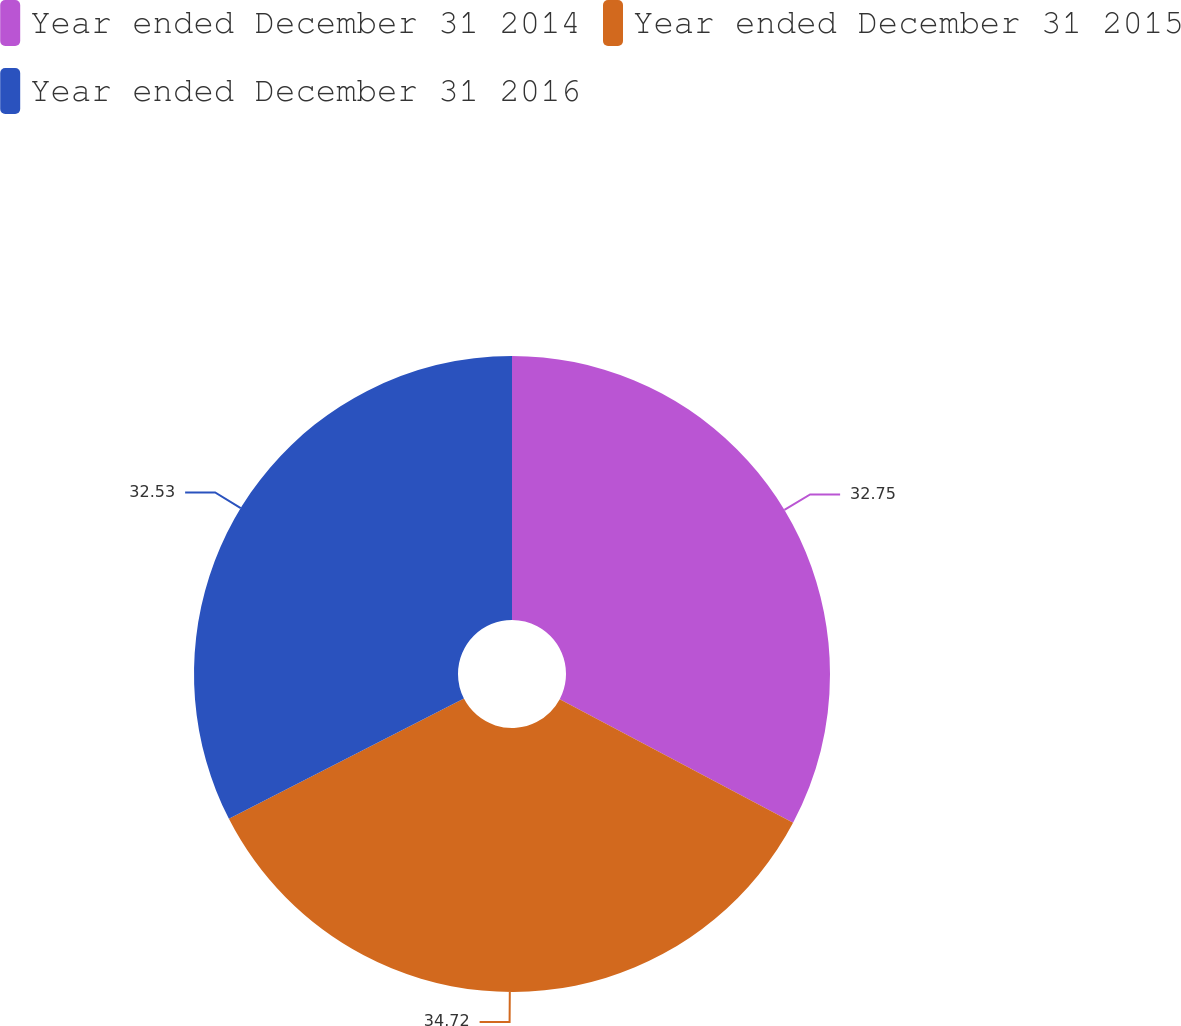<chart> <loc_0><loc_0><loc_500><loc_500><pie_chart><fcel>Year ended December 31 2014<fcel>Year ended December 31 2015<fcel>Year ended December 31 2016<nl><fcel>32.75%<fcel>34.73%<fcel>32.53%<nl></chart> 